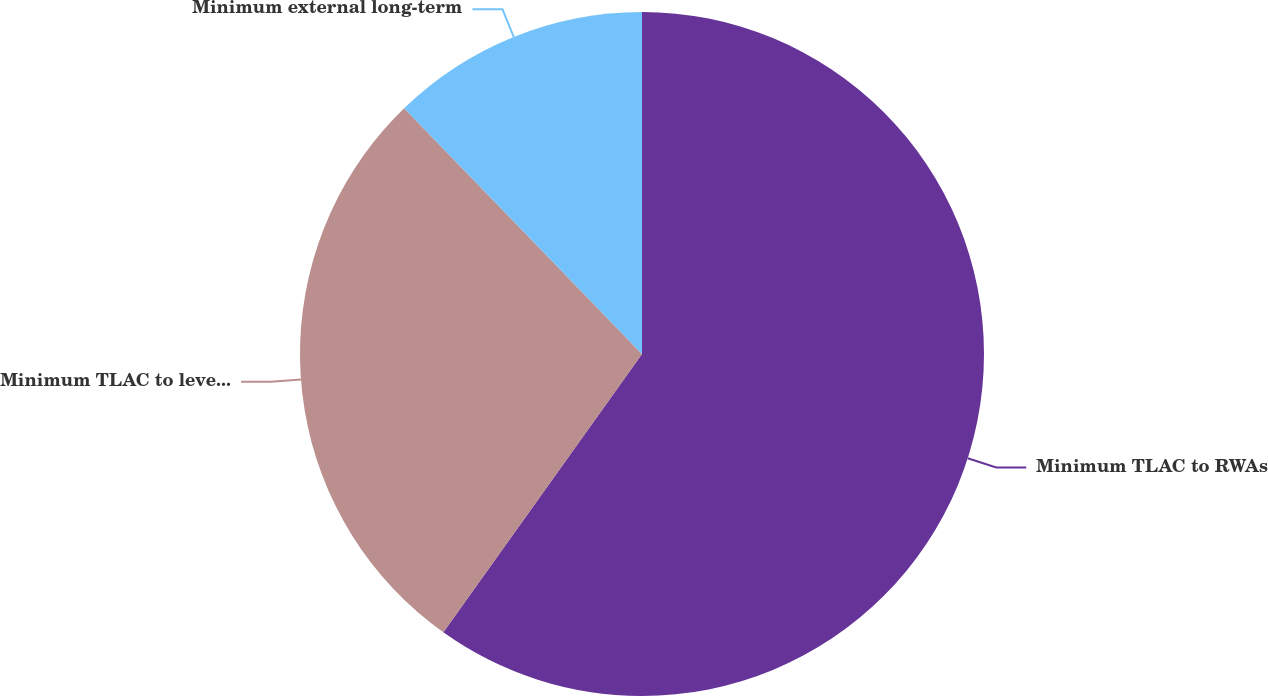Convert chart. <chart><loc_0><loc_0><loc_500><loc_500><pie_chart><fcel>Minimum TLAC to RWAs<fcel>Minimum TLAC to leverage<fcel>Minimum external long-term<nl><fcel>59.86%<fcel>27.89%<fcel>12.24%<nl></chart> 